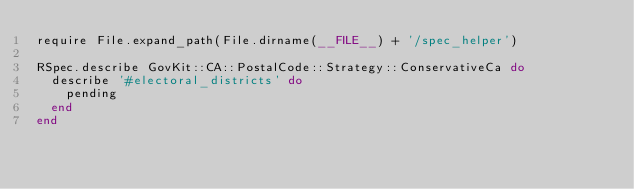<code> <loc_0><loc_0><loc_500><loc_500><_Ruby_>require File.expand_path(File.dirname(__FILE__) + '/spec_helper')

RSpec.describe GovKit::CA::PostalCode::Strategy::ConservativeCa do
  describe '#electoral_districts' do
    pending
  end
end
</code> 